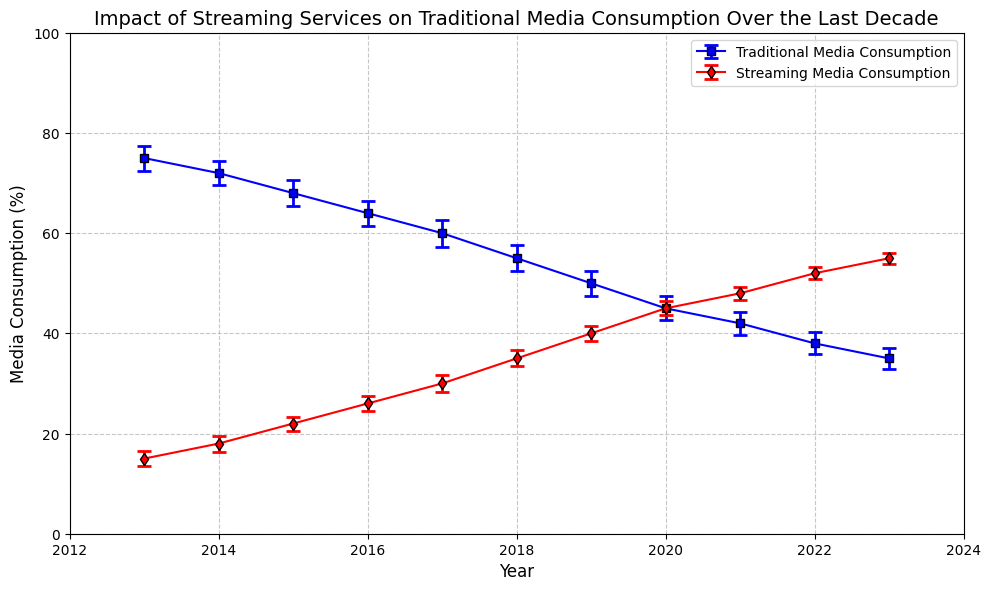What's the overall trend in Traditional Media Consumption from 2013 to 2023? The trend in Traditional Media Consumption shows a consistent decrease over the years. This is indicated by the line chart, where the blue line representing Traditional Media Consumption is steadily declining from 75% in 2013 to 35% in 2023.
Answer: Decrease Which year marked the equal consumption of Traditional Media and Streaming Media? The equal consumption of Traditional Media and Streaming Media is visually identifiable by the point where the two lines intersect. In 2020, both Traditional Media and Streaming Media are at 45%.
Answer: 2020 By how much did Streaming Media Consumption in 2023 surpass Traditional Media Consumption in 2013? Streaming Media Consumption in 2023 is 55%, while Traditional Media Consumption in 2013 is 75%. The difference between the two is calculated as 75 - 55.
Answer: 20% In which year did Streaming Media Consumption first exceed 30%? Streaming Media Consumption surpassed 30% in 2017 as indicated by the red line crossing the 30% mark on the y-axis in that year.
Answer: 2017 What is the average Traditional Media Consumption for the first three years (2013-2015) shown in the chart? The Traditional Media Consumption for the years 2013, 2014, and 2015 are 75%, 72%, and 68% respectively. The average is calculated as (75 + 72 + 68) / 3.
Answer: 71.7% Which type of media showed less variability in consumption over the decade, as indicated by the size of the error bars? By visually inspecting the error bars, it can be seen that the Streaming Media Consumption has smaller error bars than Traditional Media Consumption, indicating less variability.
Answer: Streaming Media What was the combined consumption of Traditional and Streaming Media in 2021? In 2021, Traditional Media Consumption is 42% and Streaming Media Consumption is 48%. Their combined consumption is calculated as 42 + 48.
Answer: 90% Which year shows the highest decrease in Traditional Media Consumption compared to the previous year? The largest decrease in Traditional Media Consumption occurs between 2018 and 2019, where the consumption drops from 55% to 50%, a decrease of 5%.
Answer: 2019 What color represents Traditional Media Consumption in the chart? The color that represents Traditional Media Consumption is visually indicated by the blue line and markers.
Answer: Blue 